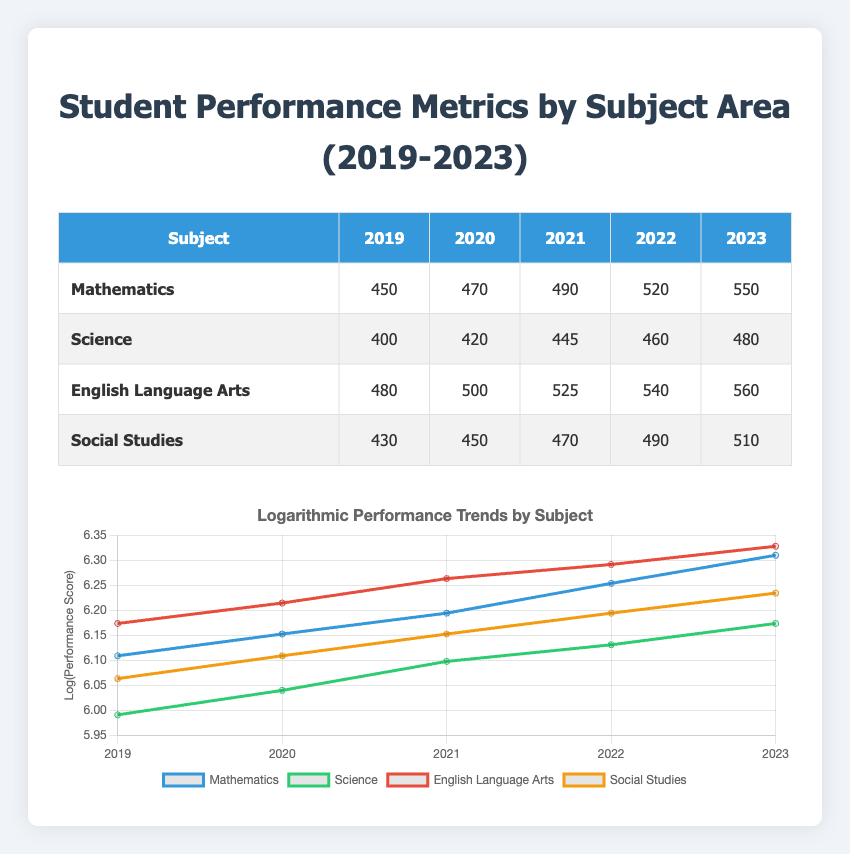What was the performance score in Mathematics for the year 2022? The table shows the performance data for Mathematics, and in the year 2022, the score listed is 520.
Answer: 520 Which subject had the highest performance score in 2023? By comparing the scores in the `2023` column for all subjects, Mathematics has the highest score, which is 550.
Answer: Mathematics What is the difference in performance scores between English Language Arts and Social Studies in 2021? From the table, the score for English Language Arts in 2021 is 525, while for Social Studies, it is 470. The difference is 525 - 470 = 55.
Answer: 55 Is the performance score in Science for 2020 greater than 420? The table indicates that the performance score in Science for 2020 is indeed 420, which means it is not greater than this value.
Answer: No What was the average performance score across all subjects for the year 2019? The scores for 2019 are Mathematics: 450, Science: 400, English Language Arts: 480, and Social Studies: 430. First, sum them up: 450 + 400 + 480 + 430 = 1760. Then, divide by the number of subjects, which is 4: 1760 / 4 = 440.
Answer: 440 Which subject shows the most improvement in performance from 2019 to 2023? To find which subject improved the most, we calculate the changes: Mathematics (550 - 450 = 100), Science (480 - 400 = 80), English Language Arts (560 - 480 = 80), and Social Studies (510 - 430 = 80). Mathematics shows the greatest improvement of 100.
Answer: Mathematics Was there any subject that had a lower score in 2021 compared to 2020? By examining the scores for each subject, all subjects showed an increase from 2020 to 2021. Mathematics increased from 470 to 490, Science from 420 to 445, English Language Arts from 500 to 525, and Social Studies from 450 to 470. Thus, the answer is no.
Answer: No What is the total performance score for Mathematics over the five years? The scores for Mathematics are 450, 470, 490, 520, and 550. Adding these together gives: 450 + 470 + 490 + 520 + 550 = 2480.
Answer: 2480 